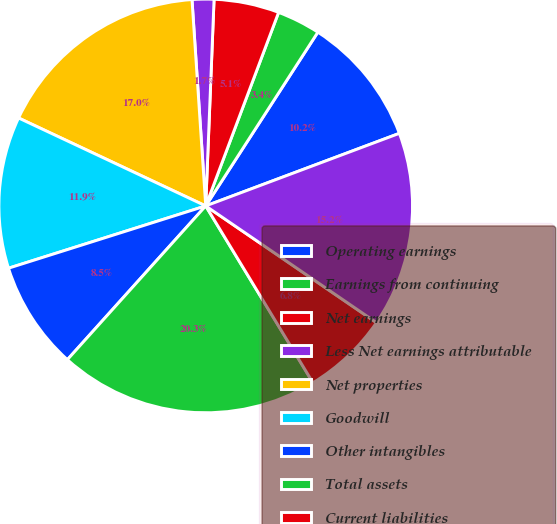<chart> <loc_0><loc_0><loc_500><loc_500><pie_chart><fcel>Operating earnings<fcel>Earnings from continuing<fcel>Net earnings<fcel>Less Net earnings attributable<fcel>Net properties<fcel>Goodwill<fcel>Other intangibles<fcel>Total assets<fcel>Current liabilities<fcel>Long-term borrowings<nl><fcel>10.17%<fcel>3.39%<fcel>5.09%<fcel>1.7%<fcel>16.95%<fcel>11.86%<fcel>8.47%<fcel>20.34%<fcel>6.78%<fcel>15.25%<nl></chart> 